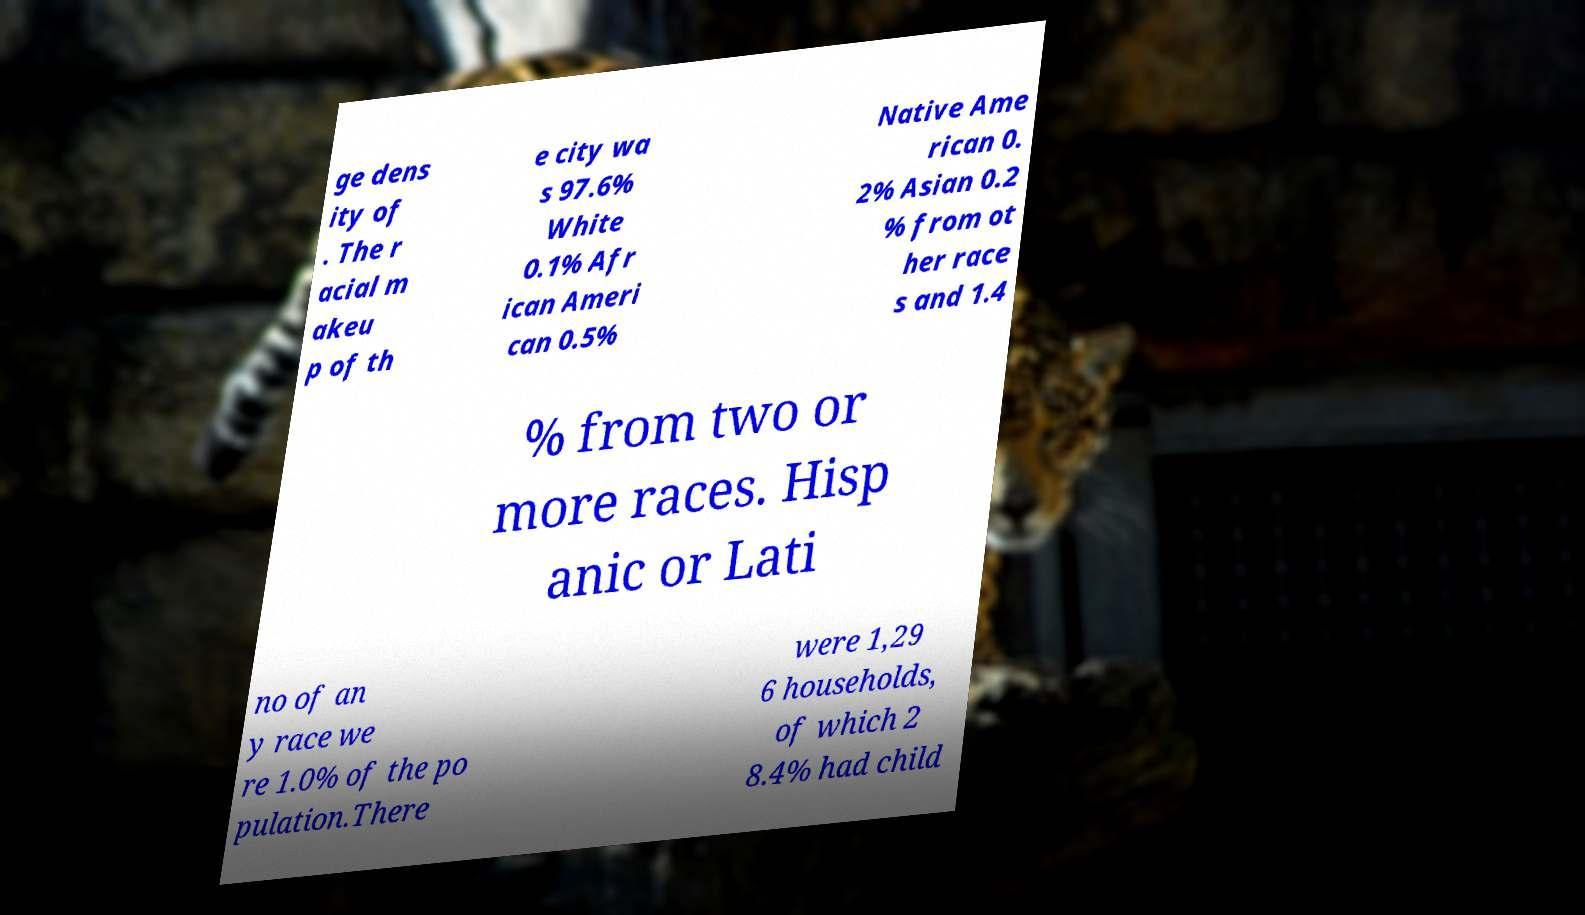What messages or text are displayed in this image? I need them in a readable, typed format. ge dens ity of . The r acial m akeu p of th e city wa s 97.6% White 0.1% Afr ican Ameri can 0.5% Native Ame rican 0. 2% Asian 0.2 % from ot her race s and 1.4 % from two or more races. Hisp anic or Lati no of an y race we re 1.0% of the po pulation.There were 1,29 6 households, of which 2 8.4% had child 